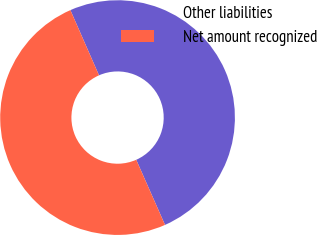<chart> <loc_0><loc_0><loc_500><loc_500><pie_chart><fcel>Other liabilities<fcel>Net amount recognized<nl><fcel>49.96%<fcel>50.04%<nl></chart> 